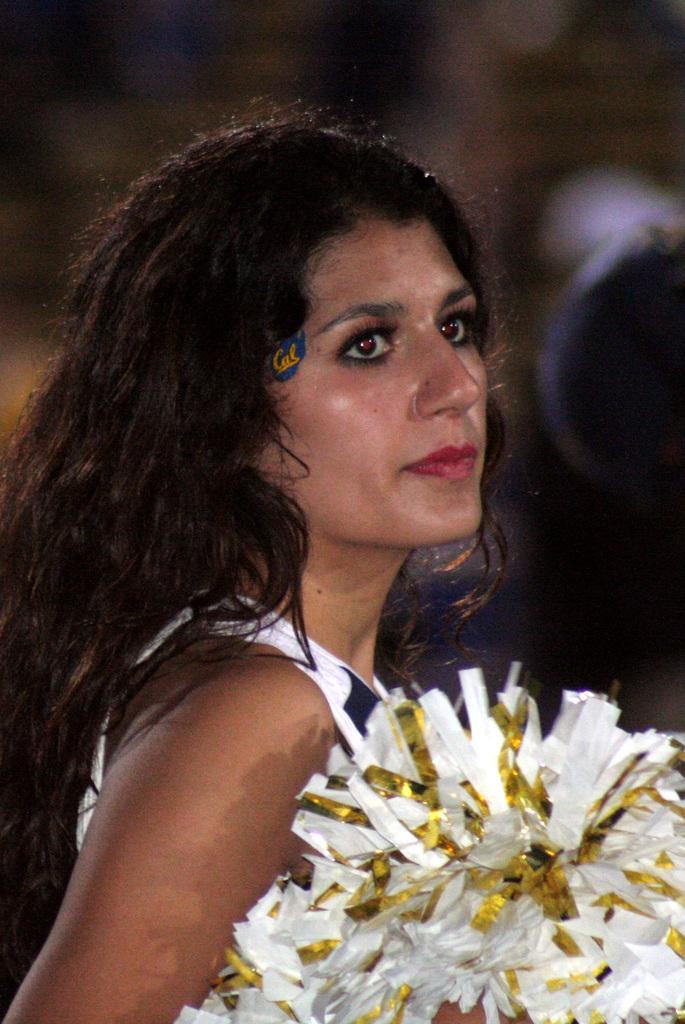Could you give a brief overview of what you see in this image? This is the woman standing. I think she is holding a cheerleader pom poms. The background looks blurry. 